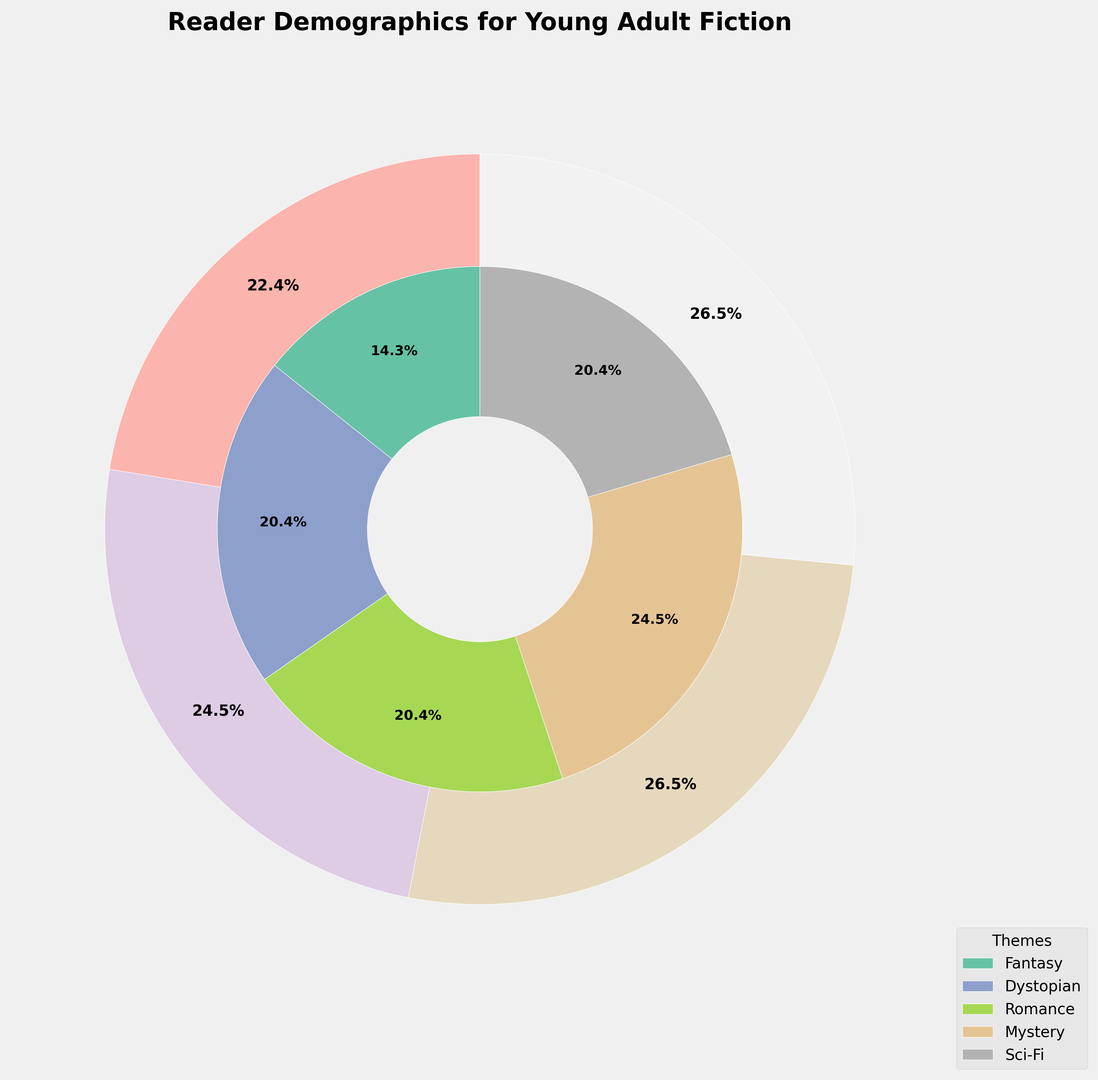What age group has the highest percentage of readers preferring Romance themes? The nested pie chart shows various percentages for different age groups and themes. By looking at the sections representing Romance, we see that the 19-21 age group has the largest share.
Answer: 19-21 What is the combined percentage of readers aged 13-15 and 16-18? Adding the percentages for the age groups 13-15 (20% + 15% + 10% + 5% + 5% = 55%) and 16-18 (15% + 10% + 15% + 10% + 10% = 60%) gives us 55% + 60% = 115%.
Answer: 115% Which theme has the smallest percentage across all age groups? By examining the inner sections of the pie chart, we see that Dystopian has the smallest segment compared to other themes.
Answer: Dystopian Between the 13-15 and 22-25 age groups, which spends more percentage on Sci-Fi? The 13-15 age group has a 5% share of Sci-Fi, and the 22-25 age group has a 20% share. 22-25 has a higher percentage.
Answer: 22-25 Which age group has the least aggregated percentage? From the outer sections of the pie chart, the 22-25 age group has the least aggregated percentage when compared to other age groups.
Answer: 22-25 What’s the most preferred theme for the 16-18 age group? Looking at the outer circle for the 16-18 age group and seeing which inner circle section (theme) represents the largest percentage, we find that Fantasy and Romance both have equal shares.
Answer: Fantasy and Romance Among Fantasy and Mystery themes, which one is preferred more by readers aged 22-25? Fantasy has a 5% share while Mystery has a 20% share in the 22-25 age group. Mystery is preferred more.
Answer: Mystery What is the total percentage of readers preferring Sci-Fi across all age groups? Summing the Sci-Fi values across all age groups: 5% (13-15) + 10% (16-18) + 15% (19-21) + 20% (22-25) = 50%
Answer: 50% What proportion of the 19-21 age group prefers Mystery books? From the chart, the percentage of 19-21 readers who prefer Mystery is shown as 15%.
Answer: 15% Comparing readers' preference for Romance between the 13-15 and 16-18 age groups, which one is higher? The 13-15 age group has a 10% share for Romance, and the 16-18 age group has a 15% share. Thus, 16-18 has a higher preference.
Answer: 16-18 